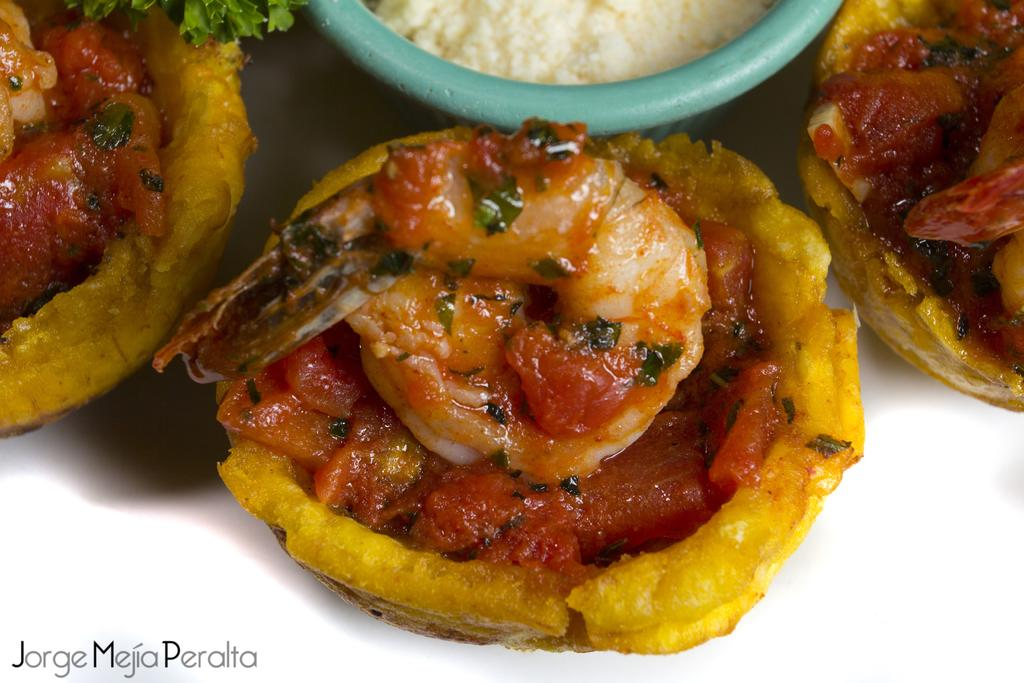What types of items can be seen in the picture? There are eatable items in the picture. Can you describe the container in the picture? There is a bowl in the picture. What type of beetle can be seen playing the bells in the image? There is no beetle or bells present in the image. 